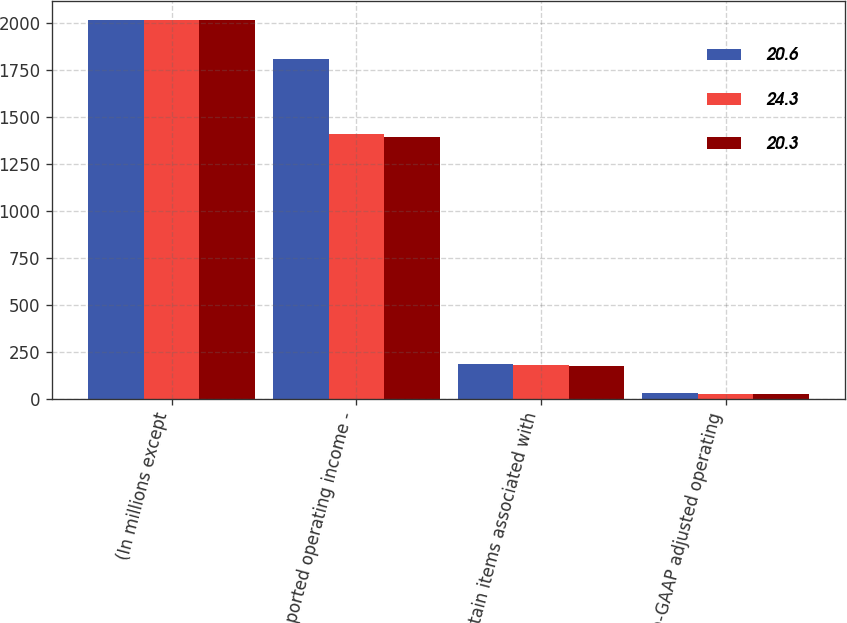Convert chart to OTSL. <chart><loc_0><loc_0><loc_500><loc_500><stacked_bar_chart><ecel><fcel>(In millions except<fcel>Reported operating income -<fcel>Certain items associated with<fcel>Non-GAAP adjusted operating<nl><fcel>20.6<fcel>2016<fcel>1807<fcel>184<fcel>29<nl><fcel>24.3<fcel>2015<fcel>1410<fcel>178<fcel>25.9<nl><fcel>20.3<fcel>2014<fcel>1391<fcel>172<fcel>26.2<nl></chart> 